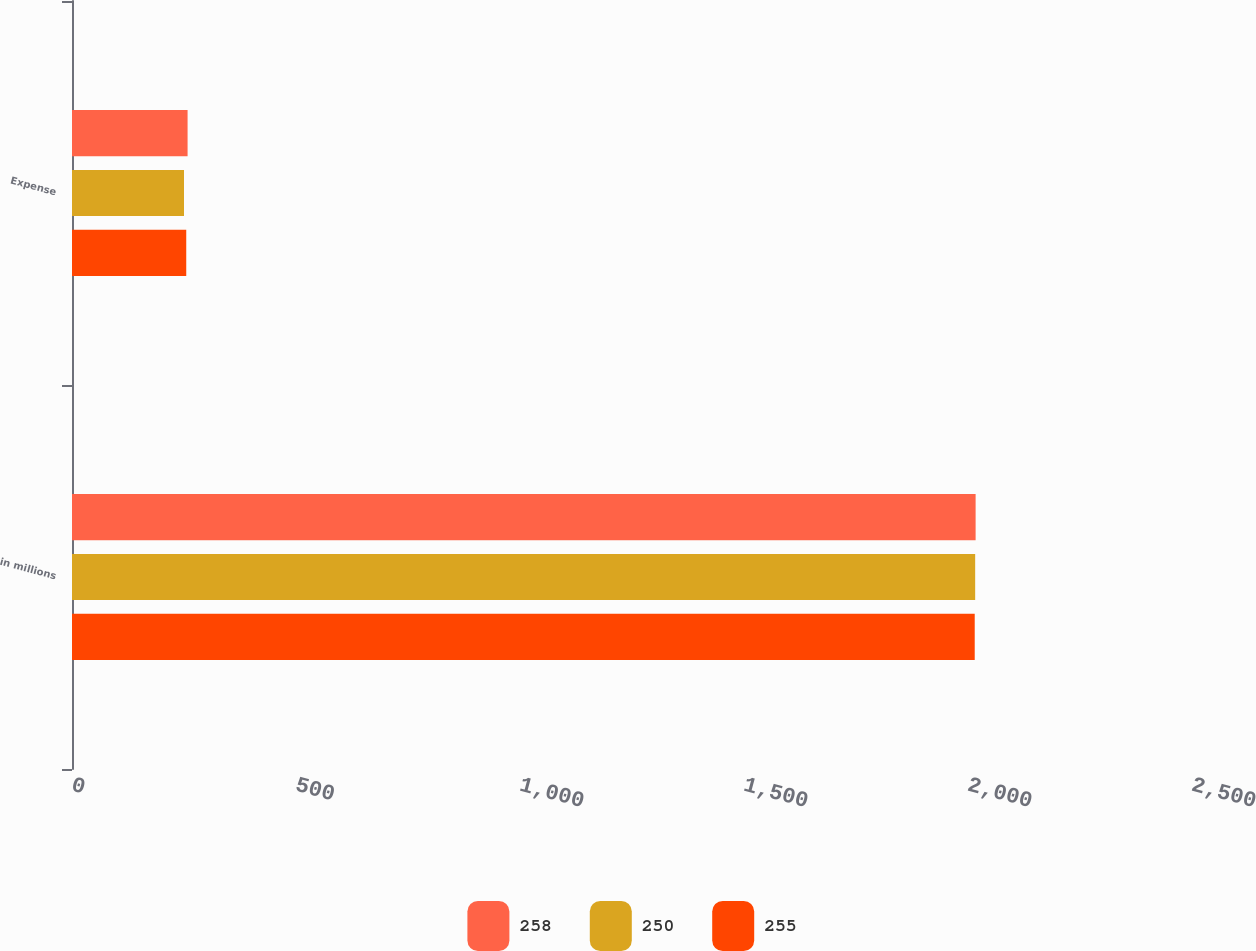Convert chart to OTSL. <chart><loc_0><loc_0><loc_500><loc_500><stacked_bar_chart><ecel><fcel>in millions<fcel>Expense<nl><fcel>258<fcel>2017<fcel>258<nl><fcel>250<fcel>2016<fcel>250<nl><fcel>255<fcel>2015<fcel>255<nl></chart> 